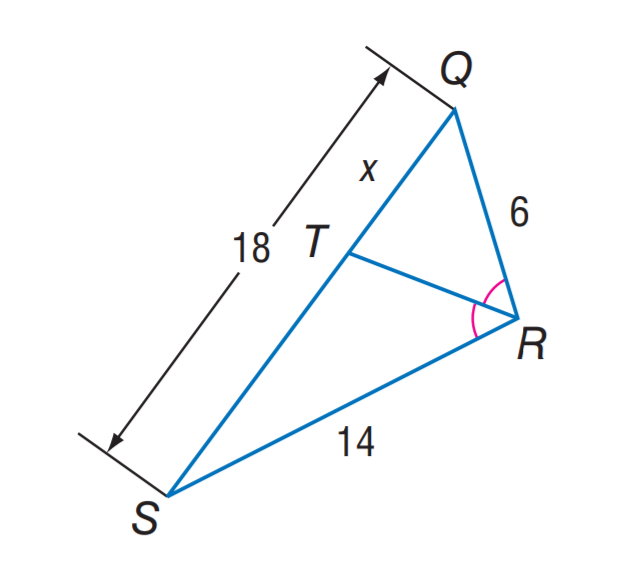Question: Find x.
Choices:
A. 2.7
B. 5.4
C. 6
D. 9
Answer with the letter. Answer: B 